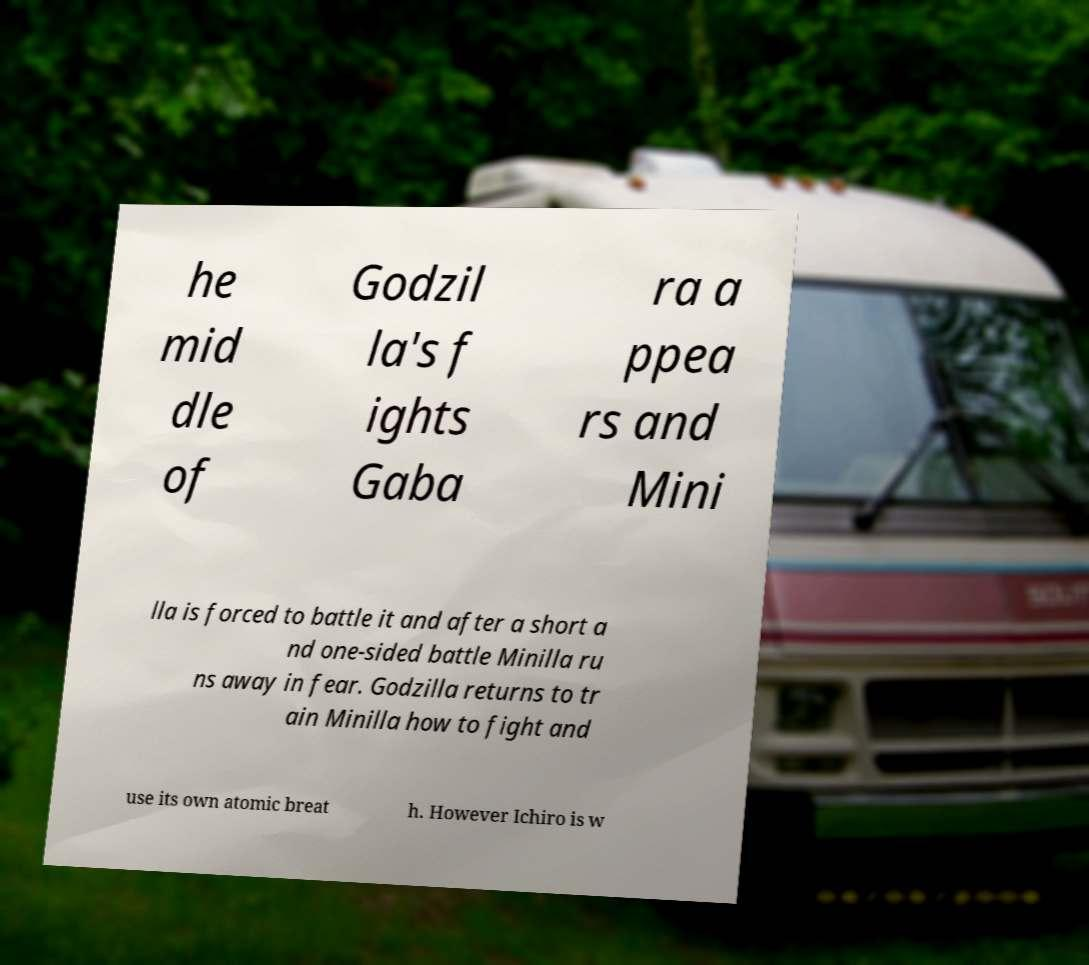Can you read and provide the text displayed in the image?This photo seems to have some interesting text. Can you extract and type it out for me? he mid dle of Godzil la's f ights Gaba ra a ppea rs and Mini lla is forced to battle it and after a short a nd one-sided battle Minilla ru ns away in fear. Godzilla returns to tr ain Minilla how to fight and use its own atomic breat h. However Ichiro is w 